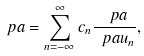Convert formula to latex. <formula><loc_0><loc_0><loc_500><loc_500>\ p a = \sum _ { n = - \infty } ^ { \infty } c _ { n } \frac { \ p a } { \ p a u _ { n } } ,</formula> 